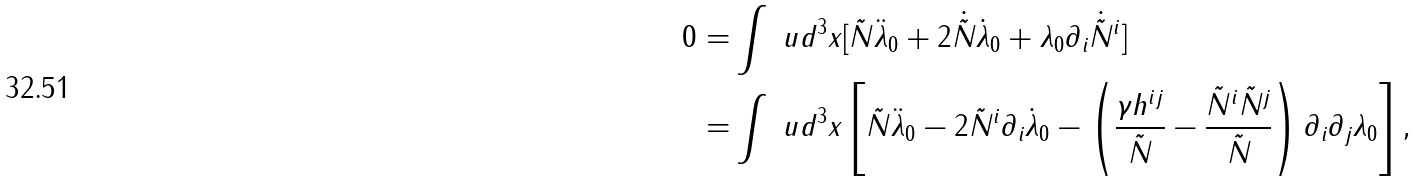Convert formula to latex. <formula><loc_0><loc_0><loc_500><loc_500>0 = & \int \ u d ^ { 3 } x [ \tilde { N } \ddot { \lambda } _ { 0 } + 2 \dot { \tilde { N } } \dot { \lambda } _ { 0 } + \lambda _ { 0 } \partial _ { i } \dot { \tilde { N } } ^ { i } ] \\ = & \int \ u d ^ { 3 } x \left [ \tilde { N } \ddot { \lambda } _ { 0 } - 2 \tilde { N } ^ { i } \partial _ { i } \dot { \lambda } _ { 0 } - \left ( \frac { \gamma h ^ { i j } } { \tilde { N } } - \frac { \tilde { N } ^ { i } \tilde { N } ^ { j } } { \tilde { N } } \right ) \partial _ { i } \partial _ { j } \lambda _ { 0 } \right ] ,</formula> 